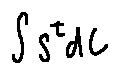Convert formula to latex. <formula><loc_0><loc_0><loc_500><loc_500>\int S ^ { t } d C</formula> 